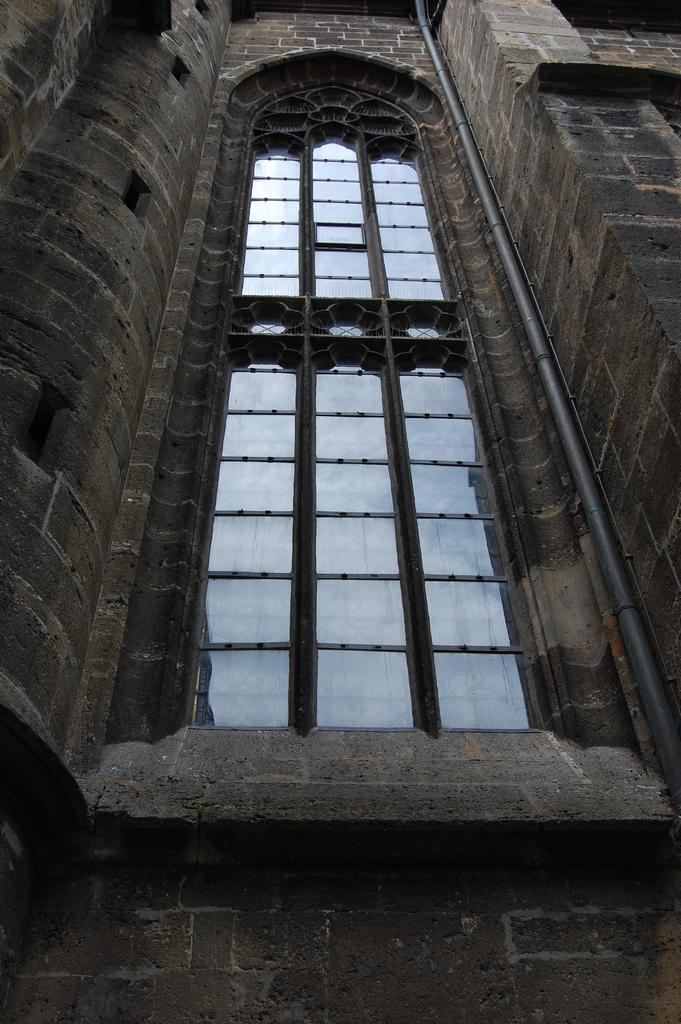What type of structure is visible in the image? There is a building in the image. What feature can be seen on the building? The building has windows. What color is the building in the image? The building is grey in color. What type of water is flowing through the building in the image? There is no water flowing through the building in the image; it is a solid structure. 